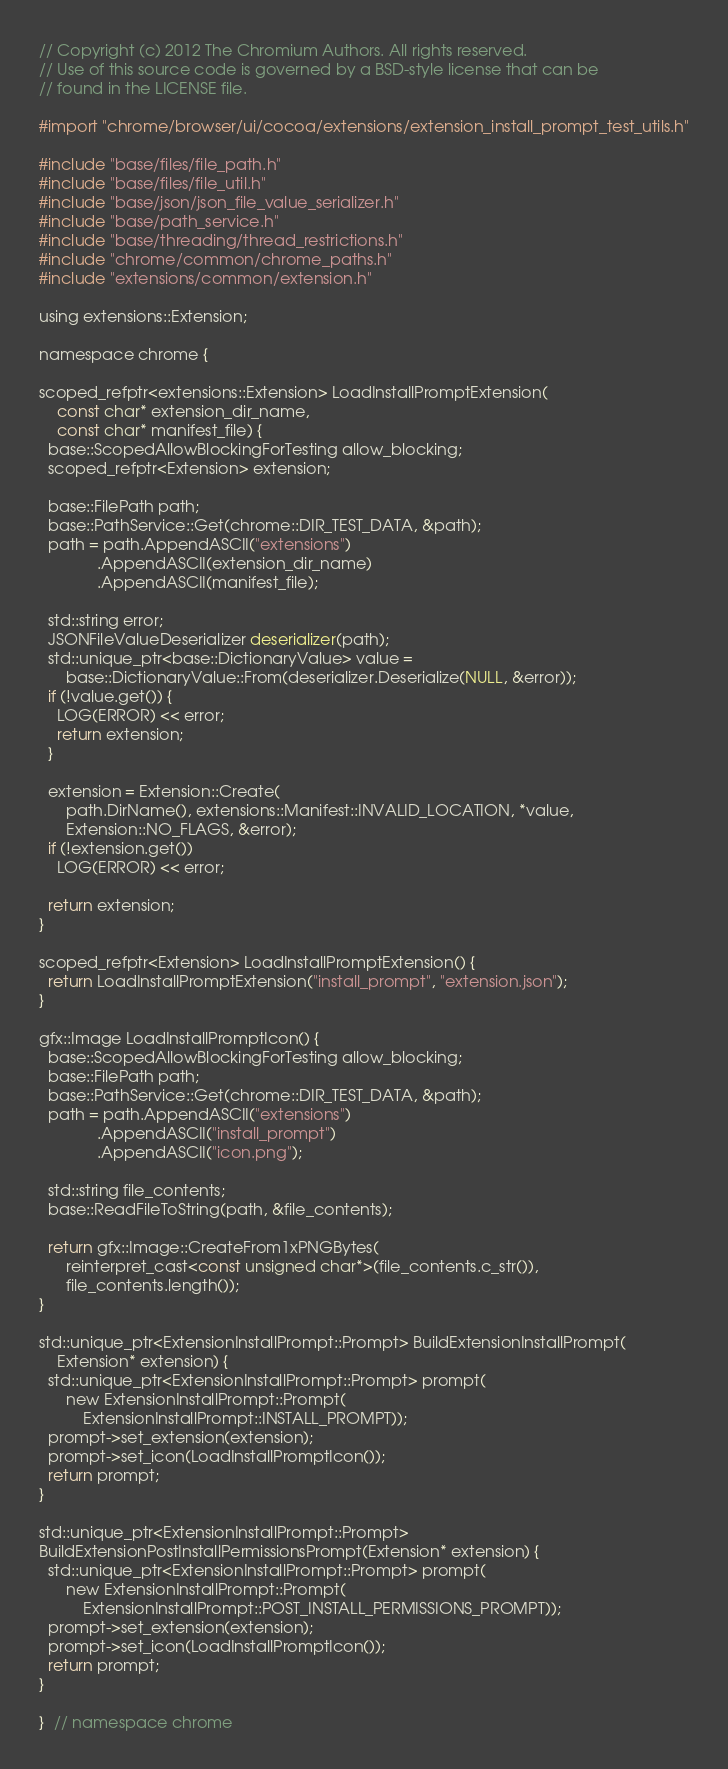Convert code to text. <code><loc_0><loc_0><loc_500><loc_500><_ObjectiveC_>// Copyright (c) 2012 The Chromium Authors. All rights reserved.
// Use of this source code is governed by a BSD-style license that can be
// found in the LICENSE file.

#import "chrome/browser/ui/cocoa/extensions/extension_install_prompt_test_utils.h"

#include "base/files/file_path.h"
#include "base/files/file_util.h"
#include "base/json/json_file_value_serializer.h"
#include "base/path_service.h"
#include "base/threading/thread_restrictions.h"
#include "chrome/common/chrome_paths.h"
#include "extensions/common/extension.h"

using extensions::Extension;

namespace chrome {

scoped_refptr<extensions::Extension> LoadInstallPromptExtension(
    const char* extension_dir_name,
    const char* manifest_file) {
  base::ScopedAllowBlockingForTesting allow_blocking;
  scoped_refptr<Extension> extension;

  base::FilePath path;
  base::PathService::Get(chrome::DIR_TEST_DATA, &path);
  path = path.AppendASCII("extensions")
             .AppendASCII(extension_dir_name)
             .AppendASCII(manifest_file);

  std::string error;
  JSONFileValueDeserializer deserializer(path);
  std::unique_ptr<base::DictionaryValue> value =
      base::DictionaryValue::From(deserializer.Deserialize(NULL, &error));
  if (!value.get()) {
    LOG(ERROR) << error;
    return extension;
  }

  extension = Extension::Create(
      path.DirName(), extensions::Manifest::INVALID_LOCATION, *value,
      Extension::NO_FLAGS, &error);
  if (!extension.get())
    LOG(ERROR) << error;

  return extension;
}

scoped_refptr<Extension> LoadInstallPromptExtension() {
  return LoadInstallPromptExtension("install_prompt", "extension.json");
}

gfx::Image LoadInstallPromptIcon() {
  base::ScopedAllowBlockingForTesting allow_blocking;
  base::FilePath path;
  base::PathService::Get(chrome::DIR_TEST_DATA, &path);
  path = path.AppendASCII("extensions")
             .AppendASCII("install_prompt")
             .AppendASCII("icon.png");

  std::string file_contents;
  base::ReadFileToString(path, &file_contents);

  return gfx::Image::CreateFrom1xPNGBytes(
      reinterpret_cast<const unsigned char*>(file_contents.c_str()),
      file_contents.length());
}

std::unique_ptr<ExtensionInstallPrompt::Prompt> BuildExtensionInstallPrompt(
    Extension* extension) {
  std::unique_ptr<ExtensionInstallPrompt::Prompt> prompt(
      new ExtensionInstallPrompt::Prompt(
          ExtensionInstallPrompt::INSTALL_PROMPT));
  prompt->set_extension(extension);
  prompt->set_icon(LoadInstallPromptIcon());
  return prompt;
}

std::unique_ptr<ExtensionInstallPrompt::Prompt>
BuildExtensionPostInstallPermissionsPrompt(Extension* extension) {
  std::unique_ptr<ExtensionInstallPrompt::Prompt> prompt(
      new ExtensionInstallPrompt::Prompt(
          ExtensionInstallPrompt::POST_INSTALL_PERMISSIONS_PROMPT));
  prompt->set_extension(extension);
  prompt->set_icon(LoadInstallPromptIcon());
  return prompt;
}

}  // namespace chrome
</code> 